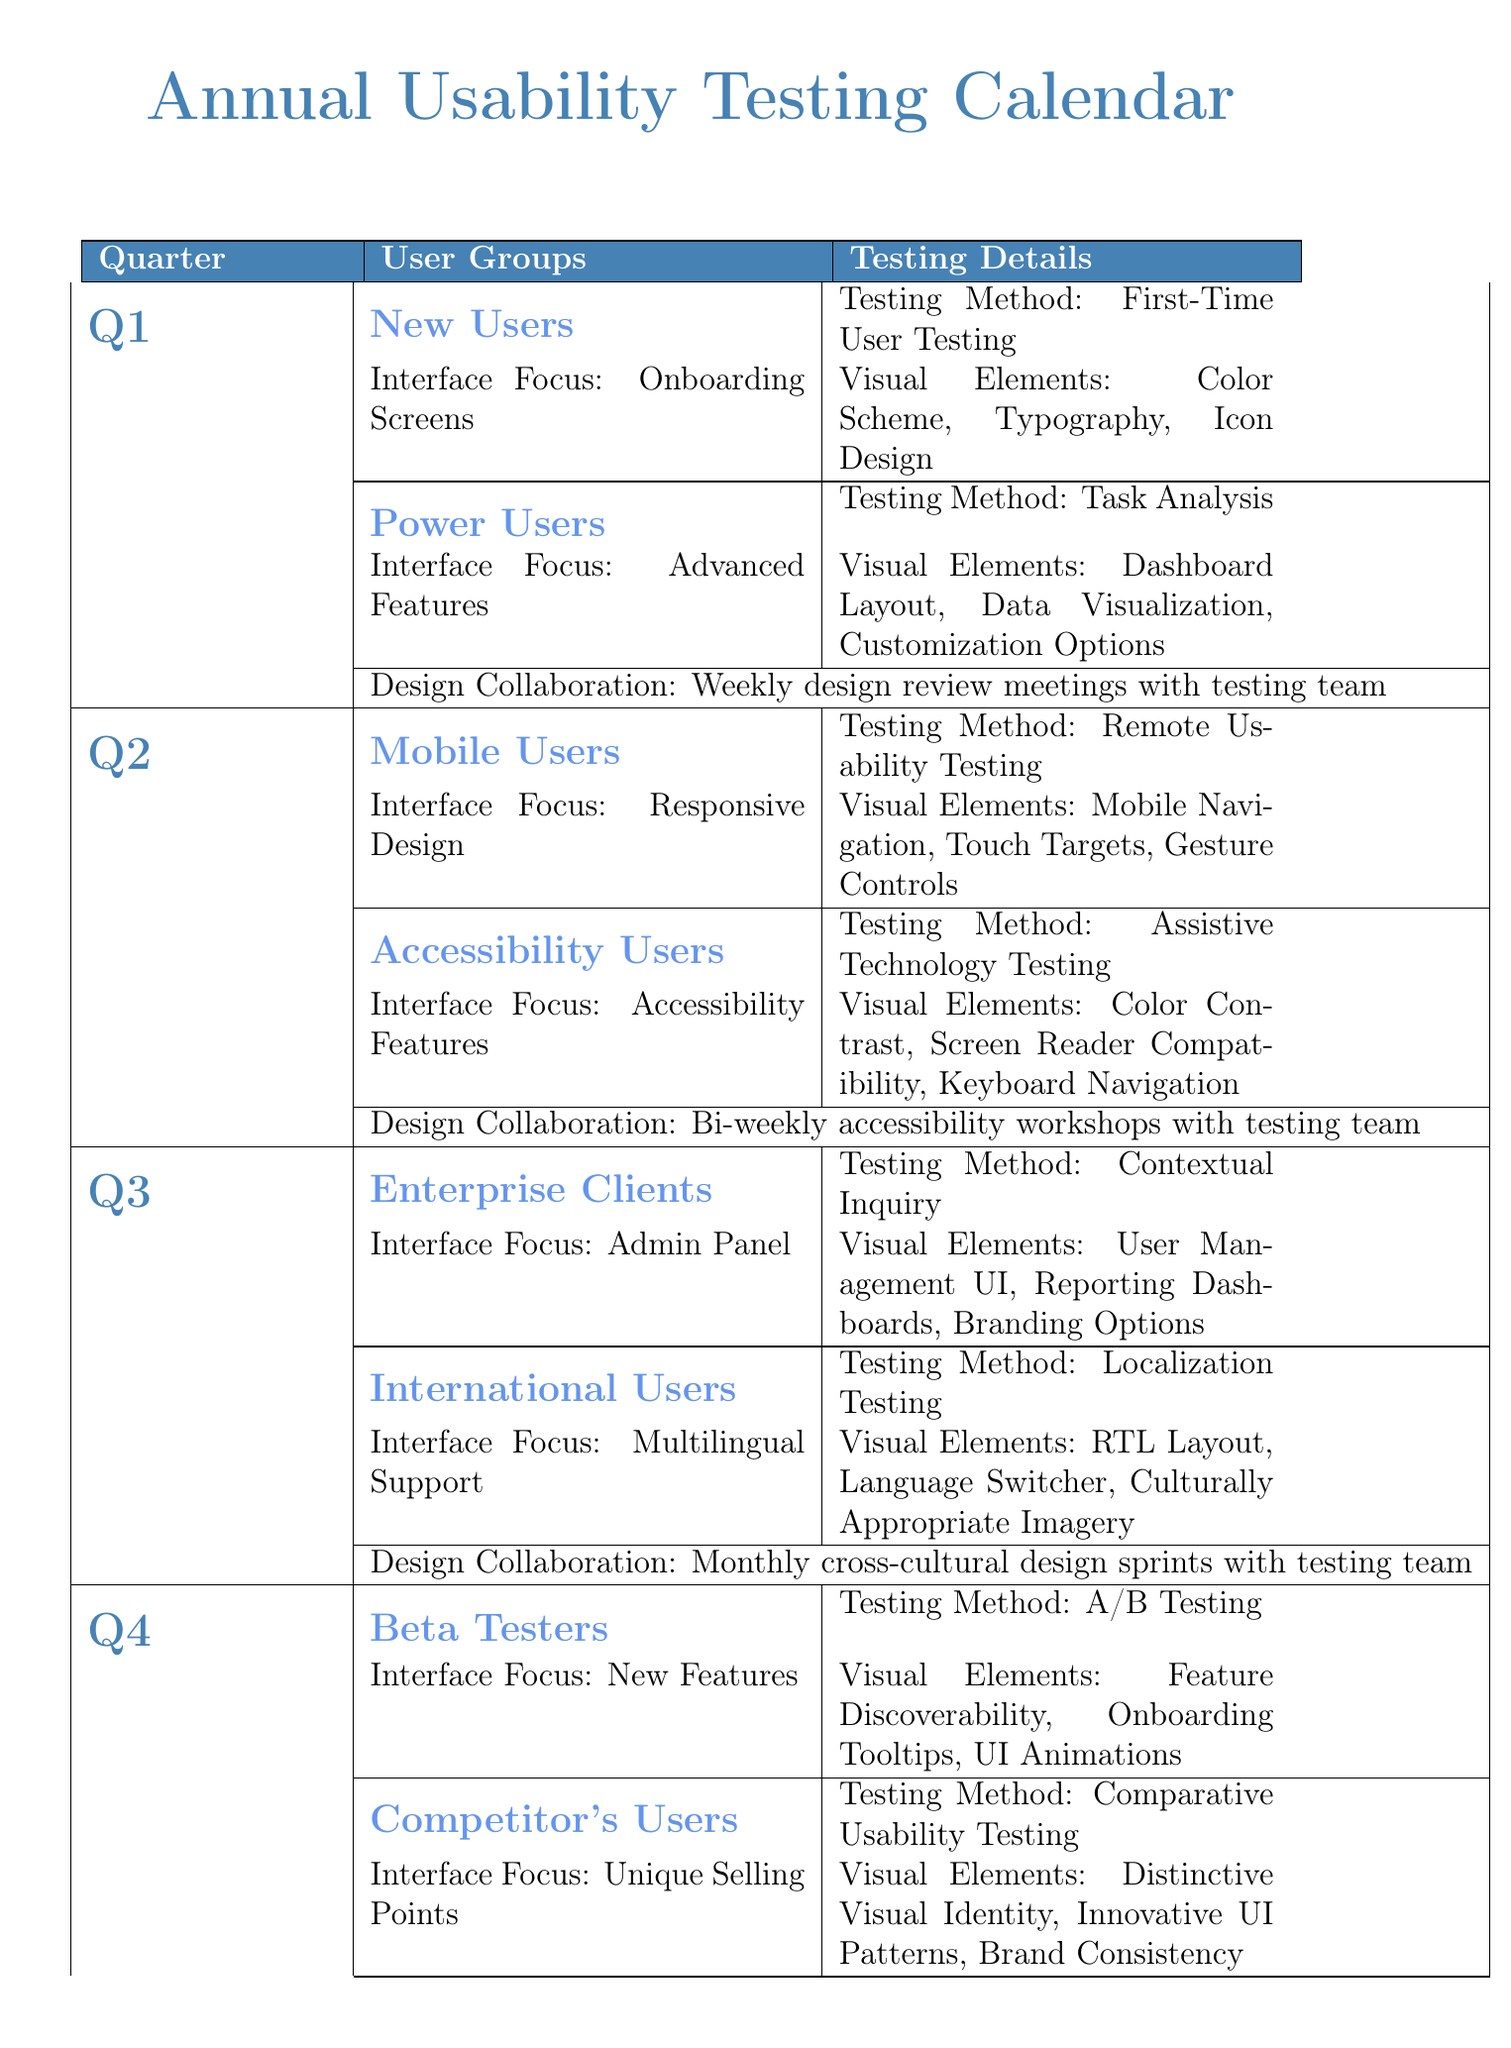What are the user groups tested in Q1? The user groups mentioned in Q1 are "New Users" and "Power Users".
Answer: New Users, Power Users What testing method is used for Mobile Users in Q2? The testing method used for Mobile Users is "Remote Usability Testing".
Answer: Remote Usability Testing Which user group focuses on Admin Panel interface in Q3? The user group focusing on the Admin Panel interface in Q3 is "Enterprise Clients".
Answer: Enterprise Clients How often are design collaboration meetings held in Q1? Design collaboration meetings in Q1 are held weekly as specified in the document.
Answer: Weekly What is the interface focus for Beta Testers in Q4? The interface focus for Beta Testers is "New Features".
Answer: New Features Which testing methodology analyzes users' visual attention patterns? The testing methodology that analyzes users' visual attention patterns is "Eye-Tracking Studies".
Answer: Eye-Tracking Studies What visual elements are considered for Accessibility Users in Q2? The visual elements for Accessibility Users include "Color Contrast, Screen Reader Compatibility, Keyboard Navigation".
Answer: Color Contrast, Screen Reader Compatibility, Keyboard Navigation How many user groups are tested in Q3? There are two user groups tested in Q3 as mentioned in the document.
Answer: Two What kind of report assesses the interface against WCAG guidelines? The report that assesses the interface against WCAG guidelines is called the "Accessibility Compliance Report".
Answer: Accessibility Compliance Report 